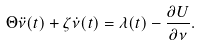<formula> <loc_0><loc_0><loc_500><loc_500>\Theta \ddot { \nu } ( t ) + \zeta \dot { \nu } ( t ) = \lambda ( t ) - \frac { \partial U } { \partial \nu } .</formula> 